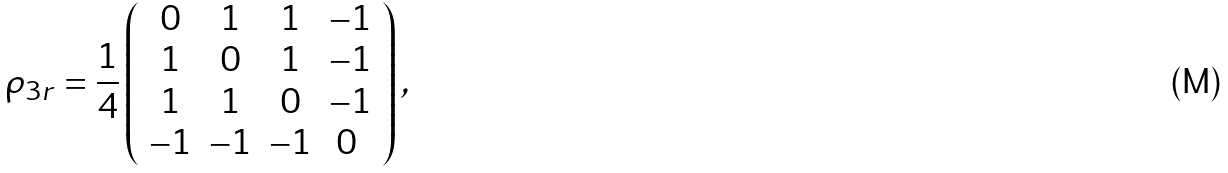<formula> <loc_0><loc_0><loc_500><loc_500>\rho _ { 3 r } = \frac { 1 } { 4 } \left ( \begin{array} { c c c c } 0 & 1 & 1 & - 1 \\ 1 & 0 & 1 & - 1 \\ 1 & 1 & 0 & - 1 \\ - 1 & - 1 & - 1 & 0 \ \end{array} \right ) ,</formula> 